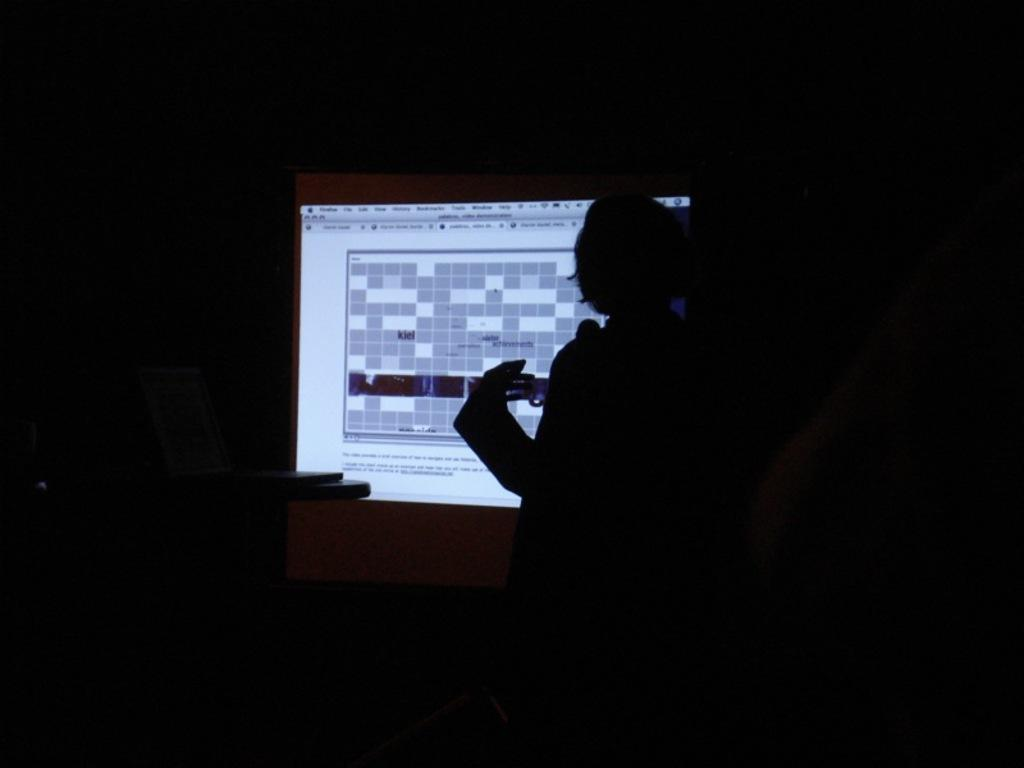Who or what is the main subject in the image? There is a person in the image. What is the person doing or interacting with in the image? The person is in front of a screen. What is the color of the background in the image? The background of the image is black. What type of honey is being used to read the cheese in the image? There is no honey or cheese present in the image, and therefore no such activity can be observed. 